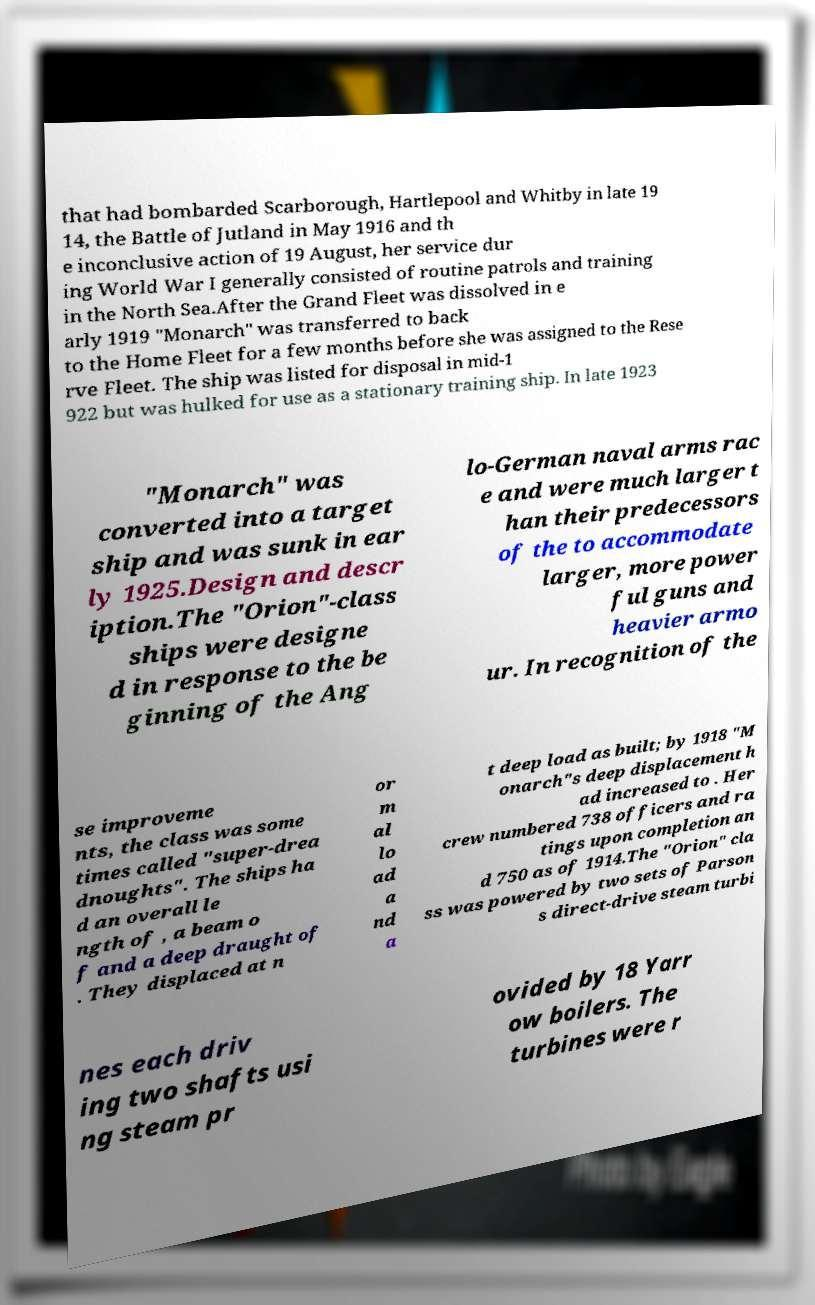There's text embedded in this image that I need extracted. Can you transcribe it verbatim? that had bombarded Scarborough, Hartlepool and Whitby in late 19 14, the Battle of Jutland in May 1916 and th e inconclusive action of 19 August, her service dur ing World War I generally consisted of routine patrols and training in the North Sea.After the Grand Fleet was dissolved in e arly 1919 "Monarch" was transferred to back to the Home Fleet for a few months before she was assigned to the Rese rve Fleet. The ship was listed for disposal in mid-1 922 but was hulked for use as a stationary training ship. In late 1923 "Monarch" was converted into a target ship and was sunk in ear ly 1925.Design and descr iption.The "Orion"-class ships were designe d in response to the be ginning of the Ang lo-German naval arms rac e and were much larger t han their predecessors of the to accommodate larger, more power ful guns and heavier armo ur. In recognition of the se improveme nts, the class was some times called "super-drea dnoughts". The ships ha d an overall le ngth of , a beam o f and a deep draught of . They displaced at n or m al lo ad a nd a t deep load as built; by 1918 "M onarch"s deep displacement h ad increased to . Her crew numbered 738 officers and ra tings upon completion an d 750 as of 1914.The "Orion" cla ss was powered by two sets of Parson s direct-drive steam turbi nes each driv ing two shafts usi ng steam pr ovided by 18 Yarr ow boilers. The turbines were r 